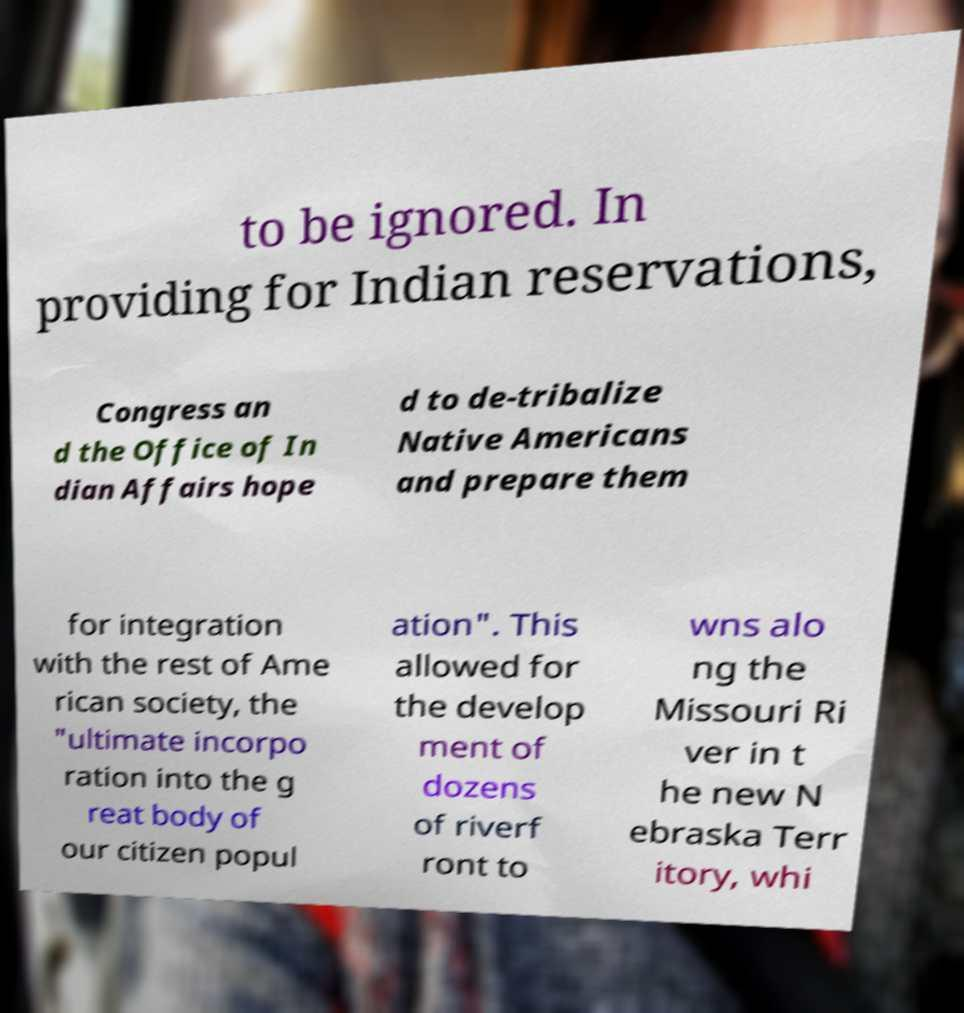I need the written content from this picture converted into text. Can you do that? to be ignored. In providing for Indian reservations, Congress an d the Office of In dian Affairs hope d to de-tribalize Native Americans and prepare them for integration with the rest of Ame rican society, the "ultimate incorpo ration into the g reat body of our citizen popul ation". This allowed for the develop ment of dozens of riverf ront to wns alo ng the Missouri Ri ver in t he new N ebraska Terr itory, whi 